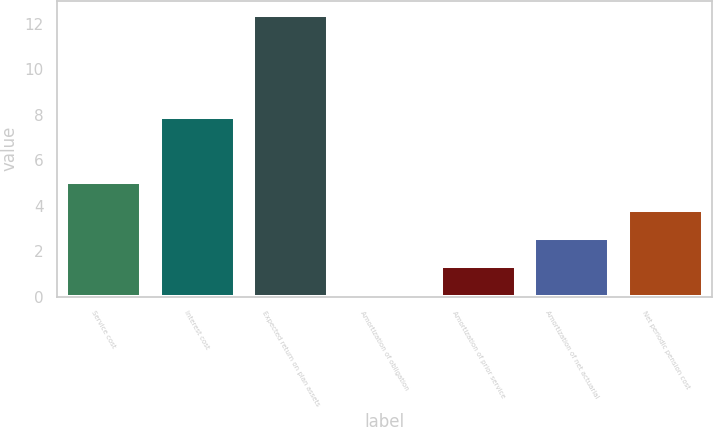Convert chart to OTSL. <chart><loc_0><loc_0><loc_500><loc_500><bar_chart><fcel>Service cost<fcel>Interest cost<fcel>Expected return on plan assets<fcel>Amortization of obligation<fcel>Amortization of prior service<fcel>Amortization of net actuarial<fcel>Net periodic pension cost<nl><fcel>5.02<fcel>7.9<fcel>12.4<fcel>0.1<fcel>1.33<fcel>2.56<fcel>3.79<nl></chart> 